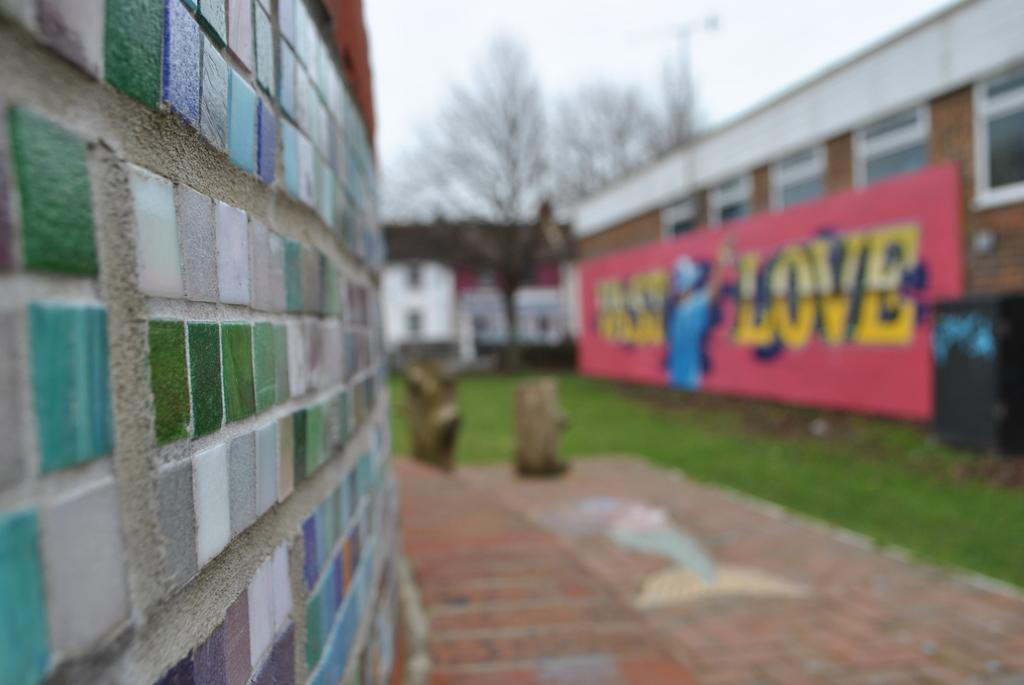What type of structure can be seen in the image? There is a wall in the image. What are the buildings in the image like? The buildings in the image have windows. Is there any text visible in the image? Yes, there is a board with text in the image. What can be found near the wall in the image? There is a trash bin in the image. What type of natural elements are present in the image? There are wooden logs, grass, and trees in the image. What part of the natural environment is visible in the image? The sky is visible in the image. What type of lipstick is the ghost wearing in the image? There is no ghost or lipstick present in the image. What is the title of the book that the wall is holding in the image? There is no book or title mentioned in the image. 